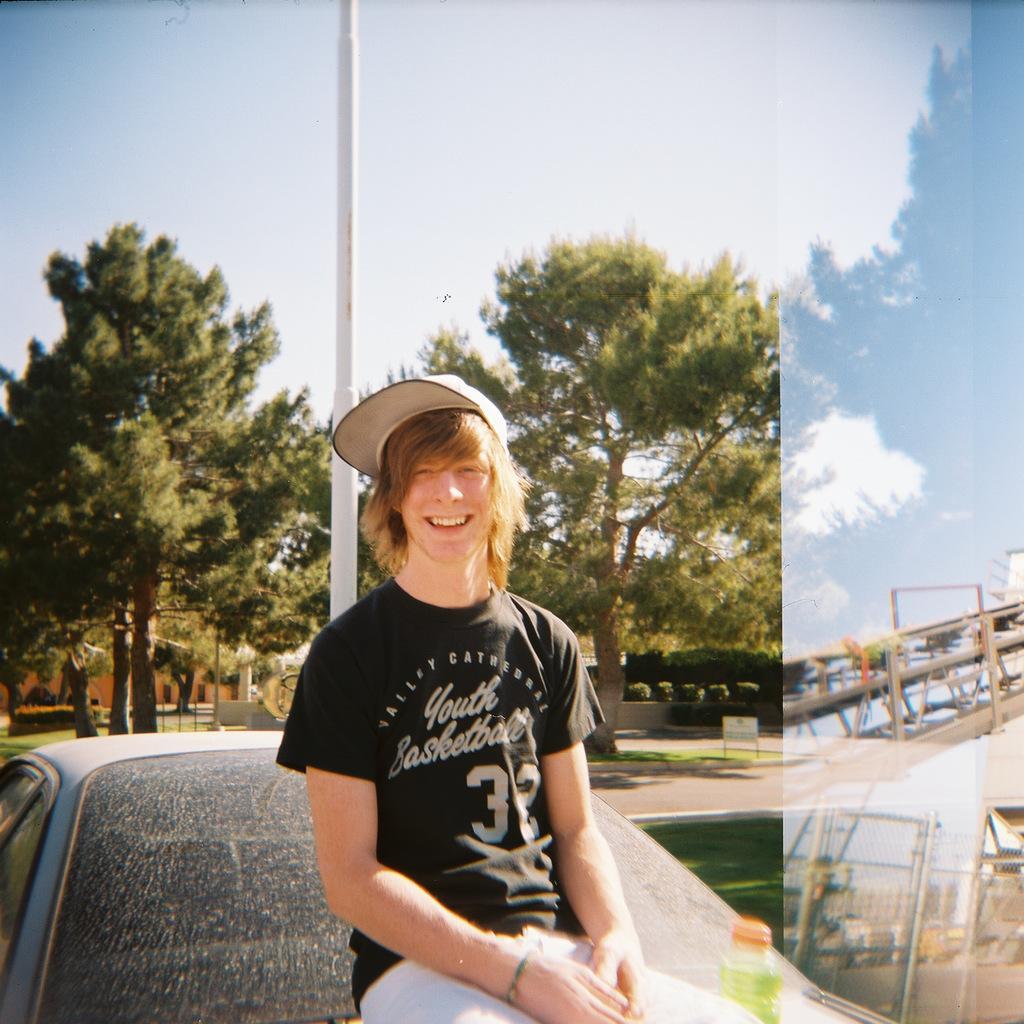In one or two sentences, can you explain what this image depicts? This looks like an edited image. I can see the man sitting on a vehicle and smiling. He wore a cap. These are the trees and bushes. This looks like a pole. On the right side of the image, that looks like an iron pillar. This is the sky. 